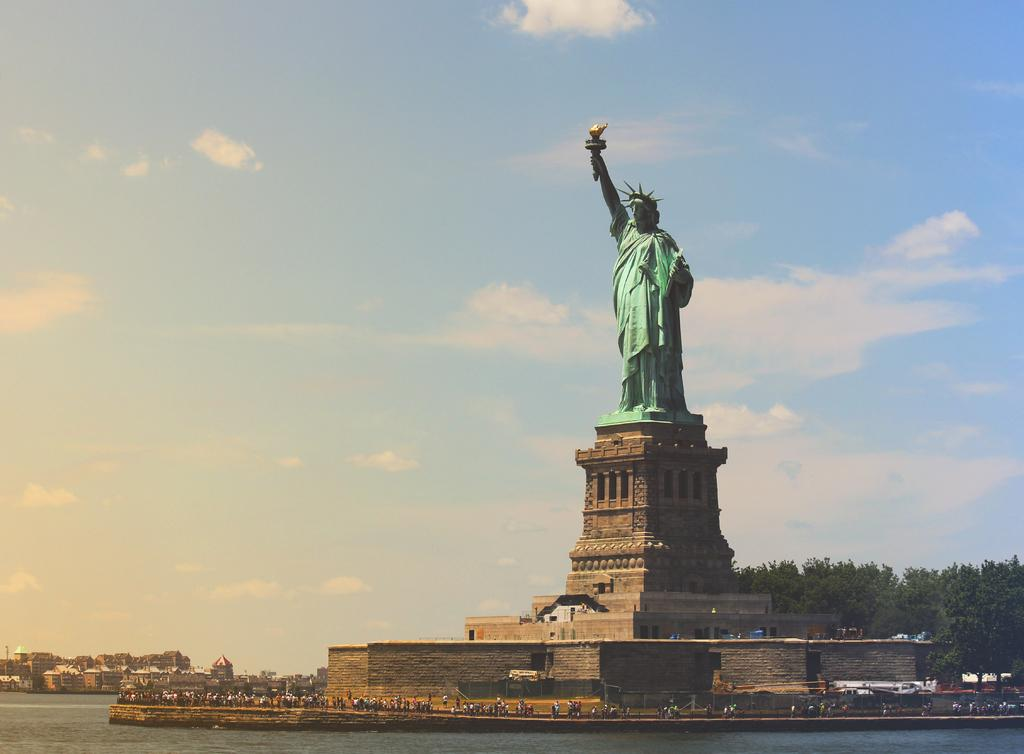What is the main subject of the image? There is a statue in the image. How is the statue positioned in the image? The statue is on a pedestal. What else can be seen in the image besides the statue? There are persons standing on the floor, water, buildings, trees, and the sky visible in the image. What is the condition of the sky in the image? The sky is visible in the image, and clouds are present. What type of creature is hiding under the statue in the image? There is no creature present under the statue in the image. What invention can be seen being used by the persons in the image? There is no specific invention visible in the image; the persons are simply standing on the floor. 